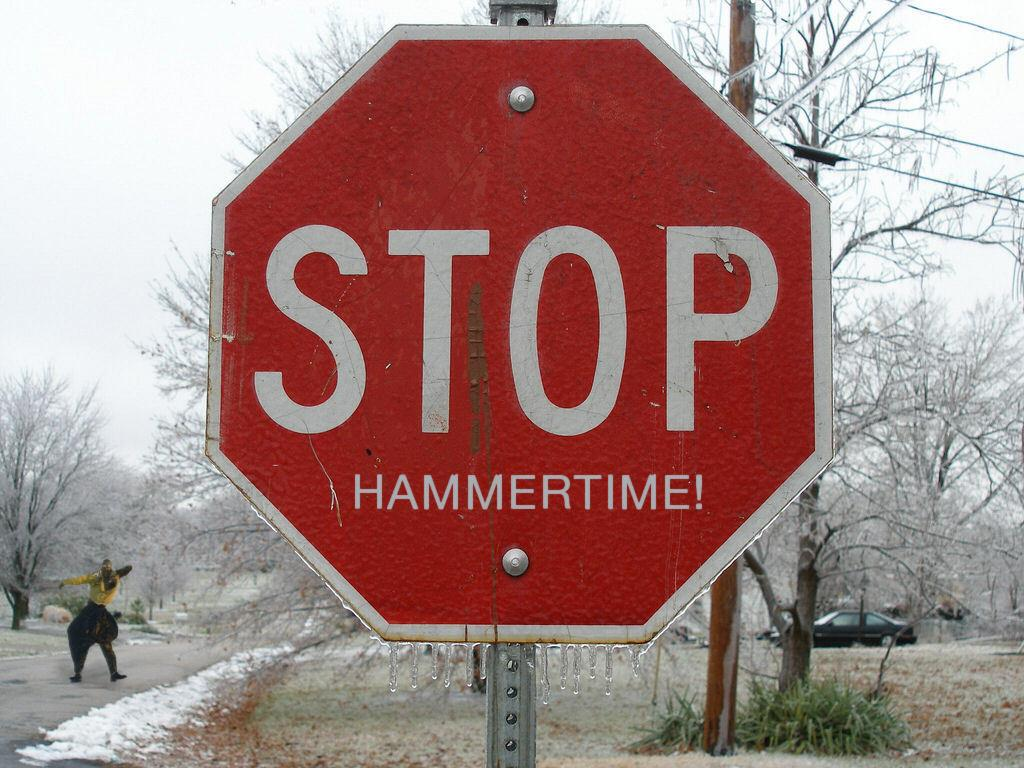<image>
Render a clear and concise summary of the photo. A Stop sign that says STOP HAMMERTIME! with a person in the background. 